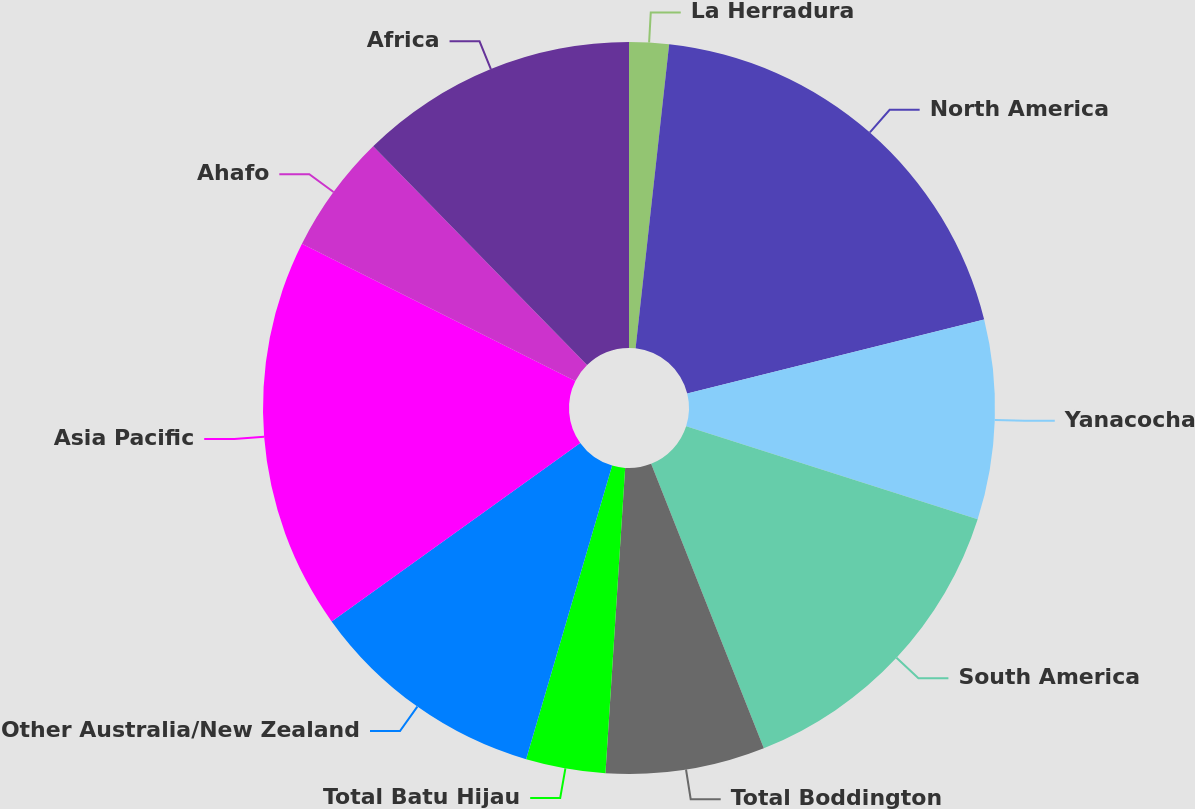<chart> <loc_0><loc_0><loc_500><loc_500><pie_chart><fcel>La Herradura<fcel>North America<fcel>Yanacocha<fcel>South America<fcel>Total Boddington<fcel>Total Batu Hijau<fcel>Other Australia/New Zealand<fcel>Asia Pacific<fcel>Ahafo<fcel>Africa<nl><fcel>1.75%<fcel>19.37%<fcel>8.8%<fcel>14.08%<fcel>7.03%<fcel>3.51%<fcel>10.56%<fcel>17.32%<fcel>5.27%<fcel>12.32%<nl></chart> 